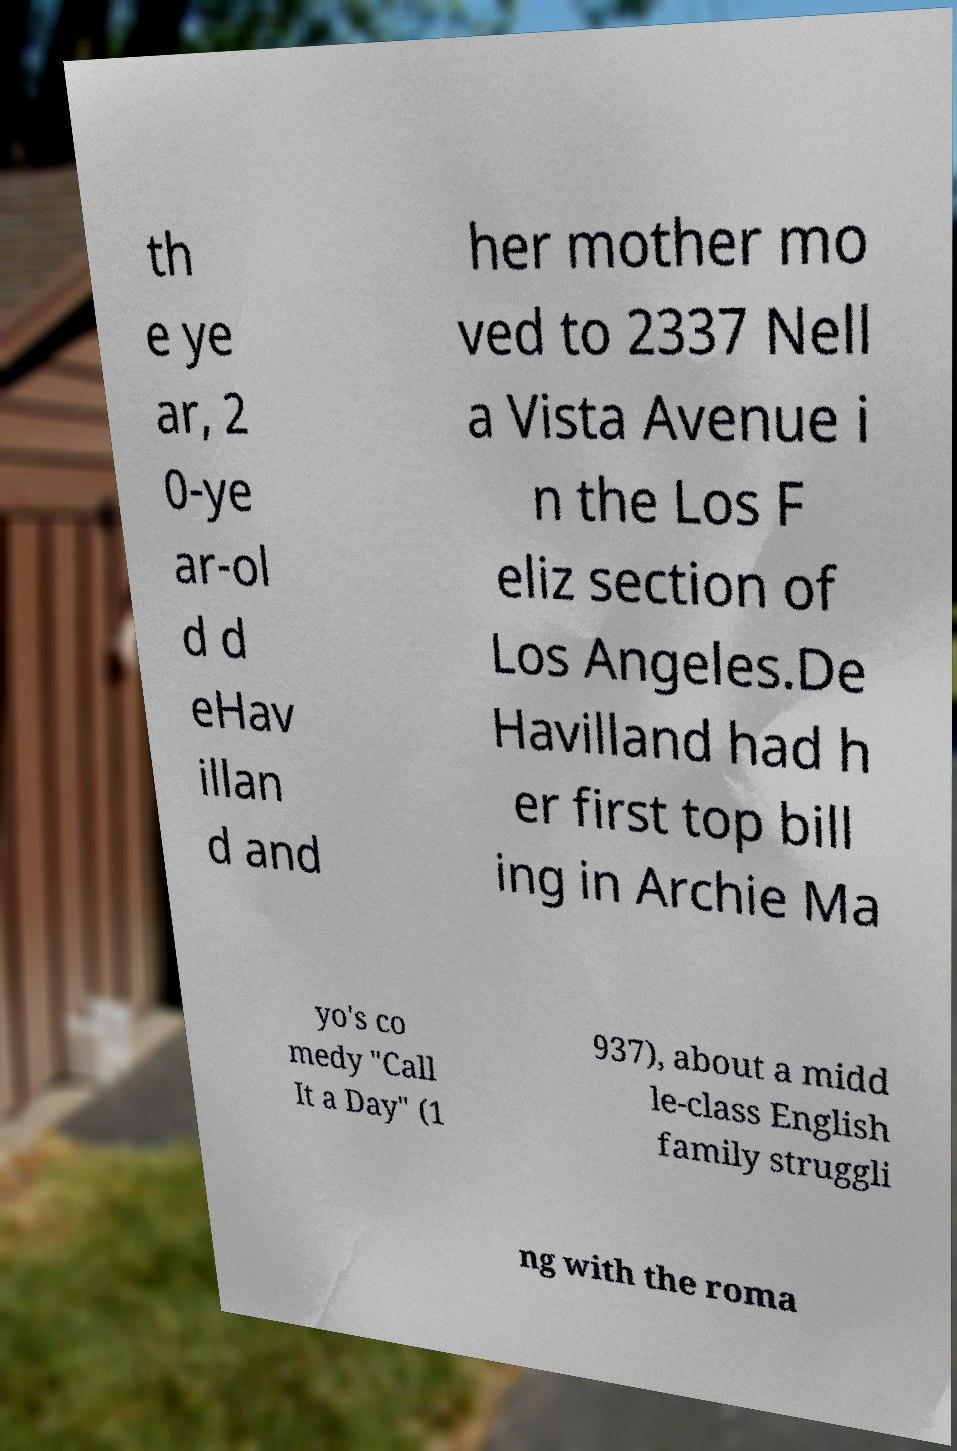Please identify and transcribe the text found in this image. th e ye ar, 2 0-ye ar-ol d d eHav illan d and her mother mo ved to 2337 Nell a Vista Avenue i n the Los F eliz section of Los Angeles.De Havilland had h er first top bill ing in Archie Ma yo's co medy "Call It a Day" (1 937), about a midd le-class English family struggli ng with the roma 